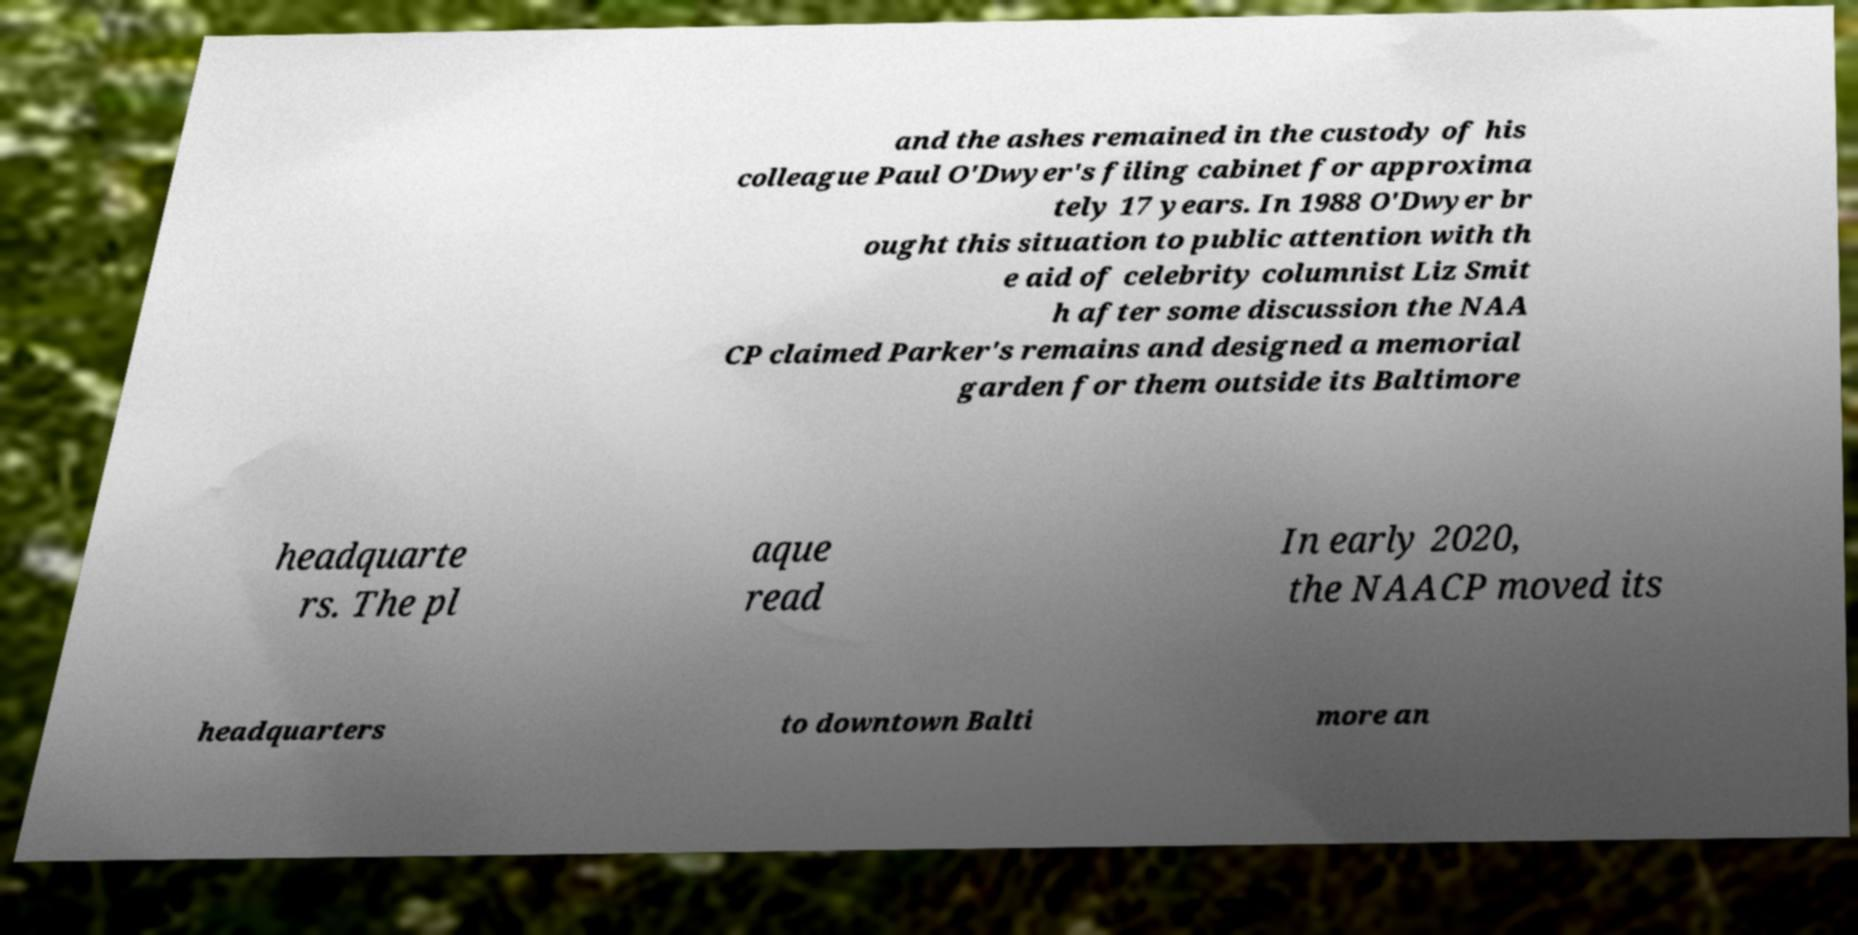Can you accurately transcribe the text from the provided image for me? and the ashes remained in the custody of his colleague Paul O'Dwyer's filing cabinet for approxima tely 17 years. In 1988 O'Dwyer br ought this situation to public attention with th e aid of celebrity columnist Liz Smit h after some discussion the NAA CP claimed Parker's remains and designed a memorial garden for them outside its Baltimore headquarte rs. The pl aque read In early 2020, the NAACP moved its headquarters to downtown Balti more an 